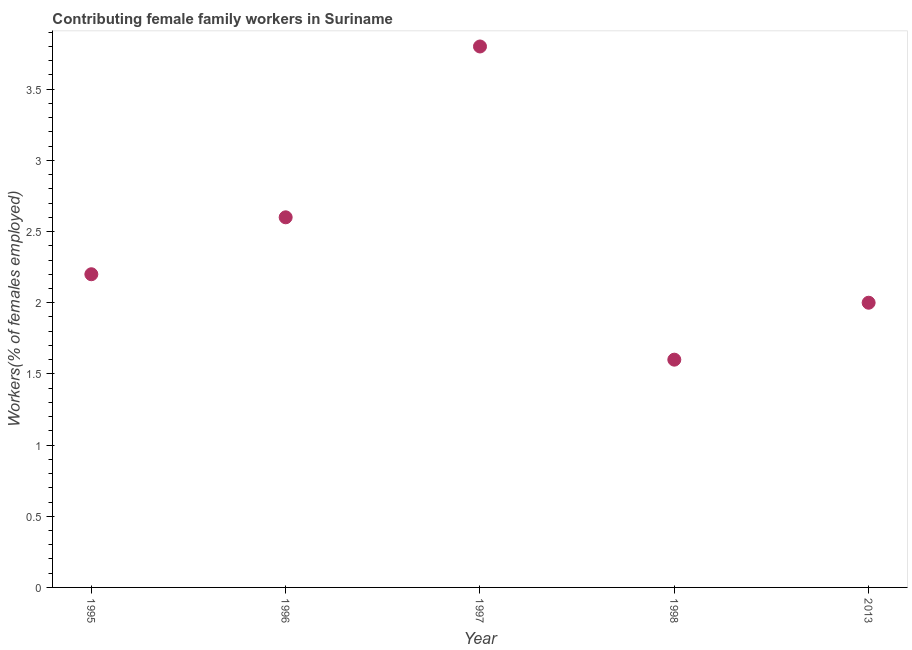Across all years, what is the maximum contributing female family workers?
Your answer should be compact. 3.8. Across all years, what is the minimum contributing female family workers?
Offer a terse response. 1.6. In which year was the contributing female family workers maximum?
Offer a terse response. 1997. What is the sum of the contributing female family workers?
Your response must be concise. 12.2. What is the difference between the contributing female family workers in 1996 and 2013?
Your response must be concise. 0.6. What is the average contributing female family workers per year?
Ensure brevity in your answer.  2.44. What is the median contributing female family workers?
Keep it short and to the point. 2.2. Do a majority of the years between 1996 and 1998 (inclusive) have contributing female family workers greater than 2.3 %?
Ensure brevity in your answer.  Yes. What is the ratio of the contributing female family workers in 1996 to that in 1997?
Your response must be concise. 0.68. Is the contributing female family workers in 1996 less than that in 1998?
Give a very brief answer. No. Is the difference between the contributing female family workers in 1995 and 2013 greater than the difference between any two years?
Your answer should be very brief. No. What is the difference between the highest and the second highest contributing female family workers?
Give a very brief answer. 1.2. What is the difference between the highest and the lowest contributing female family workers?
Your response must be concise. 2.2. How many dotlines are there?
Your answer should be very brief. 1. How many years are there in the graph?
Ensure brevity in your answer.  5. What is the title of the graph?
Keep it short and to the point. Contributing female family workers in Suriname. What is the label or title of the X-axis?
Offer a terse response. Year. What is the label or title of the Y-axis?
Make the answer very short. Workers(% of females employed). What is the Workers(% of females employed) in 1995?
Keep it short and to the point. 2.2. What is the Workers(% of females employed) in 1996?
Offer a terse response. 2.6. What is the Workers(% of females employed) in 1997?
Offer a very short reply. 3.8. What is the Workers(% of females employed) in 1998?
Offer a terse response. 1.6. What is the Workers(% of females employed) in 2013?
Ensure brevity in your answer.  2. What is the difference between the Workers(% of females employed) in 1995 and 1996?
Make the answer very short. -0.4. What is the difference between the Workers(% of females employed) in 1995 and 1997?
Offer a terse response. -1.6. What is the difference between the Workers(% of females employed) in 1996 and 1997?
Your response must be concise. -1.2. What is the difference between the Workers(% of females employed) in 1996 and 1998?
Your answer should be very brief. 1. What is the difference between the Workers(% of females employed) in 1997 and 1998?
Your answer should be compact. 2.2. What is the difference between the Workers(% of females employed) in 1998 and 2013?
Provide a succinct answer. -0.4. What is the ratio of the Workers(% of females employed) in 1995 to that in 1996?
Provide a short and direct response. 0.85. What is the ratio of the Workers(% of females employed) in 1995 to that in 1997?
Offer a very short reply. 0.58. What is the ratio of the Workers(% of females employed) in 1995 to that in 1998?
Offer a very short reply. 1.38. What is the ratio of the Workers(% of females employed) in 1995 to that in 2013?
Provide a succinct answer. 1.1. What is the ratio of the Workers(% of females employed) in 1996 to that in 1997?
Your response must be concise. 0.68. What is the ratio of the Workers(% of females employed) in 1996 to that in 1998?
Offer a terse response. 1.62. What is the ratio of the Workers(% of females employed) in 1996 to that in 2013?
Your answer should be very brief. 1.3. What is the ratio of the Workers(% of females employed) in 1997 to that in 1998?
Keep it short and to the point. 2.38. What is the ratio of the Workers(% of females employed) in 1997 to that in 2013?
Keep it short and to the point. 1.9. What is the ratio of the Workers(% of females employed) in 1998 to that in 2013?
Offer a very short reply. 0.8. 